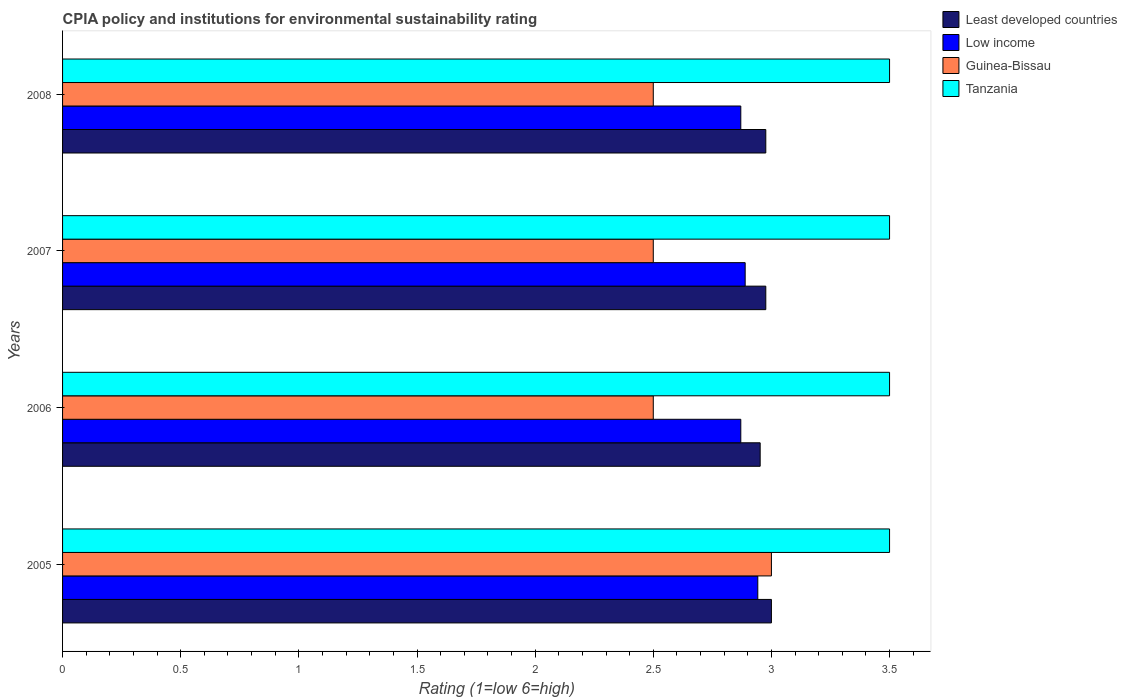How many different coloured bars are there?
Make the answer very short. 4. Are the number of bars per tick equal to the number of legend labels?
Give a very brief answer. Yes. How many bars are there on the 2nd tick from the top?
Give a very brief answer. 4. In how many cases, is the number of bars for a given year not equal to the number of legend labels?
Your response must be concise. 0. Across all years, what is the maximum CPIA rating in Low income?
Your answer should be compact. 2.94. What is the total CPIA rating in Tanzania in the graph?
Your answer should be very brief. 14. What is the difference between the CPIA rating in Least developed countries in 2006 and that in 2007?
Offer a terse response. -0.02. What is the difference between the CPIA rating in Least developed countries in 2006 and the CPIA rating in Tanzania in 2007?
Your response must be concise. -0.55. What is the average CPIA rating in Low income per year?
Offer a very short reply. 2.89. In the year 2006, what is the difference between the CPIA rating in Least developed countries and CPIA rating in Guinea-Bissau?
Keep it short and to the point. 0.45. In how many years, is the CPIA rating in Low income greater than 0.5 ?
Make the answer very short. 4. What is the ratio of the CPIA rating in Least developed countries in 2005 to that in 2006?
Keep it short and to the point. 1.02. Is the CPIA rating in Guinea-Bissau in 2006 less than that in 2008?
Keep it short and to the point. No. Is the difference between the CPIA rating in Least developed countries in 2005 and 2006 greater than the difference between the CPIA rating in Guinea-Bissau in 2005 and 2006?
Provide a succinct answer. No. What is the difference between the highest and the second highest CPIA rating in Guinea-Bissau?
Provide a succinct answer. 0.5. In how many years, is the CPIA rating in Least developed countries greater than the average CPIA rating in Least developed countries taken over all years?
Ensure brevity in your answer.  3. Is the sum of the CPIA rating in Guinea-Bissau in 2006 and 2008 greater than the maximum CPIA rating in Low income across all years?
Provide a short and direct response. Yes. Is it the case that in every year, the sum of the CPIA rating in Low income and CPIA rating in Least developed countries is greater than the sum of CPIA rating in Guinea-Bissau and CPIA rating in Tanzania?
Offer a very short reply. Yes. What does the 4th bar from the top in 2007 represents?
Ensure brevity in your answer.  Least developed countries. What does the 1st bar from the bottom in 2008 represents?
Offer a very short reply. Least developed countries. Is it the case that in every year, the sum of the CPIA rating in Tanzania and CPIA rating in Least developed countries is greater than the CPIA rating in Low income?
Give a very brief answer. Yes. Are all the bars in the graph horizontal?
Provide a short and direct response. Yes. Does the graph contain grids?
Provide a short and direct response. No. Where does the legend appear in the graph?
Your answer should be compact. Top right. What is the title of the graph?
Give a very brief answer. CPIA policy and institutions for environmental sustainability rating. What is the label or title of the X-axis?
Your answer should be very brief. Rating (1=low 6=high). What is the Rating (1=low 6=high) of Least developed countries in 2005?
Offer a terse response. 3. What is the Rating (1=low 6=high) of Low income in 2005?
Keep it short and to the point. 2.94. What is the Rating (1=low 6=high) in Guinea-Bissau in 2005?
Provide a succinct answer. 3. What is the Rating (1=low 6=high) of Least developed countries in 2006?
Provide a short and direct response. 2.95. What is the Rating (1=low 6=high) of Low income in 2006?
Make the answer very short. 2.87. What is the Rating (1=low 6=high) of Tanzania in 2006?
Your response must be concise. 3.5. What is the Rating (1=low 6=high) in Least developed countries in 2007?
Your answer should be very brief. 2.98. What is the Rating (1=low 6=high) in Low income in 2007?
Offer a terse response. 2.89. What is the Rating (1=low 6=high) in Tanzania in 2007?
Keep it short and to the point. 3.5. What is the Rating (1=low 6=high) in Least developed countries in 2008?
Give a very brief answer. 2.98. What is the Rating (1=low 6=high) in Low income in 2008?
Your answer should be compact. 2.87. Across all years, what is the maximum Rating (1=low 6=high) in Low income?
Provide a succinct answer. 2.94. Across all years, what is the maximum Rating (1=low 6=high) of Tanzania?
Your response must be concise. 3.5. Across all years, what is the minimum Rating (1=low 6=high) in Least developed countries?
Give a very brief answer. 2.95. Across all years, what is the minimum Rating (1=low 6=high) in Low income?
Your answer should be very brief. 2.87. What is the total Rating (1=low 6=high) in Least developed countries in the graph?
Ensure brevity in your answer.  11.9. What is the total Rating (1=low 6=high) in Low income in the graph?
Offer a very short reply. 11.57. What is the total Rating (1=low 6=high) of Guinea-Bissau in the graph?
Offer a very short reply. 10.5. What is the total Rating (1=low 6=high) in Tanzania in the graph?
Give a very brief answer. 14. What is the difference between the Rating (1=low 6=high) in Least developed countries in 2005 and that in 2006?
Give a very brief answer. 0.05. What is the difference between the Rating (1=low 6=high) of Low income in 2005 and that in 2006?
Give a very brief answer. 0.07. What is the difference between the Rating (1=low 6=high) in Guinea-Bissau in 2005 and that in 2006?
Ensure brevity in your answer.  0.5. What is the difference between the Rating (1=low 6=high) of Tanzania in 2005 and that in 2006?
Keep it short and to the point. 0. What is the difference between the Rating (1=low 6=high) in Least developed countries in 2005 and that in 2007?
Give a very brief answer. 0.02. What is the difference between the Rating (1=low 6=high) of Low income in 2005 and that in 2007?
Give a very brief answer. 0.05. What is the difference between the Rating (1=low 6=high) of Guinea-Bissau in 2005 and that in 2007?
Offer a very short reply. 0.5. What is the difference between the Rating (1=low 6=high) of Least developed countries in 2005 and that in 2008?
Offer a terse response. 0.02. What is the difference between the Rating (1=low 6=high) of Low income in 2005 and that in 2008?
Give a very brief answer. 0.07. What is the difference between the Rating (1=low 6=high) in Least developed countries in 2006 and that in 2007?
Your response must be concise. -0.02. What is the difference between the Rating (1=low 6=high) in Low income in 2006 and that in 2007?
Offer a very short reply. -0.02. What is the difference between the Rating (1=low 6=high) of Tanzania in 2006 and that in 2007?
Offer a very short reply. 0. What is the difference between the Rating (1=low 6=high) in Least developed countries in 2006 and that in 2008?
Ensure brevity in your answer.  -0.02. What is the difference between the Rating (1=low 6=high) in Tanzania in 2006 and that in 2008?
Keep it short and to the point. 0. What is the difference between the Rating (1=low 6=high) of Low income in 2007 and that in 2008?
Your answer should be compact. 0.02. What is the difference between the Rating (1=low 6=high) in Tanzania in 2007 and that in 2008?
Offer a very short reply. 0. What is the difference between the Rating (1=low 6=high) in Least developed countries in 2005 and the Rating (1=low 6=high) in Low income in 2006?
Your answer should be very brief. 0.13. What is the difference between the Rating (1=low 6=high) in Least developed countries in 2005 and the Rating (1=low 6=high) in Guinea-Bissau in 2006?
Give a very brief answer. 0.5. What is the difference between the Rating (1=low 6=high) in Low income in 2005 and the Rating (1=low 6=high) in Guinea-Bissau in 2006?
Offer a terse response. 0.44. What is the difference between the Rating (1=low 6=high) in Low income in 2005 and the Rating (1=low 6=high) in Tanzania in 2006?
Your answer should be compact. -0.56. What is the difference between the Rating (1=low 6=high) in Guinea-Bissau in 2005 and the Rating (1=low 6=high) in Tanzania in 2006?
Your answer should be very brief. -0.5. What is the difference between the Rating (1=low 6=high) in Least developed countries in 2005 and the Rating (1=low 6=high) in Low income in 2007?
Ensure brevity in your answer.  0.11. What is the difference between the Rating (1=low 6=high) of Least developed countries in 2005 and the Rating (1=low 6=high) of Guinea-Bissau in 2007?
Offer a terse response. 0.5. What is the difference between the Rating (1=low 6=high) in Low income in 2005 and the Rating (1=low 6=high) in Guinea-Bissau in 2007?
Make the answer very short. 0.44. What is the difference between the Rating (1=low 6=high) in Low income in 2005 and the Rating (1=low 6=high) in Tanzania in 2007?
Make the answer very short. -0.56. What is the difference between the Rating (1=low 6=high) of Least developed countries in 2005 and the Rating (1=low 6=high) of Low income in 2008?
Offer a very short reply. 0.13. What is the difference between the Rating (1=low 6=high) in Least developed countries in 2005 and the Rating (1=low 6=high) in Guinea-Bissau in 2008?
Provide a short and direct response. 0.5. What is the difference between the Rating (1=low 6=high) in Least developed countries in 2005 and the Rating (1=low 6=high) in Tanzania in 2008?
Make the answer very short. -0.5. What is the difference between the Rating (1=low 6=high) of Low income in 2005 and the Rating (1=low 6=high) of Guinea-Bissau in 2008?
Keep it short and to the point. 0.44. What is the difference between the Rating (1=low 6=high) in Low income in 2005 and the Rating (1=low 6=high) in Tanzania in 2008?
Give a very brief answer. -0.56. What is the difference between the Rating (1=low 6=high) of Least developed countries in 2006 and the Rating (1=low 6=high) of Low income in 2007?
Make the answer very short. 0.06. What is the difference between the Rating (1=low 6=high) in Least developed countries in 2006 and the Rating (1=low 6=high) in Guinea-Bissau in 2007?
Ensure brevity in your answer.  0.45. What is the difference between the Rating (1=low 6=high) of Least developed countries in 2006 and the Rating (1=low 6=high) of Tanzania in 2007?
Make the answer very short. -0.55. What is the difference between the Rating (1=low 6=high) in Low income in 2006 and the Rating (1=low 6=high) in Guinea-Bissau in 2007?
Make the answer very short. 0.37. What is the difference between the Rating (1=low 6=high) in Low income in 2006 and the Rating (1=low 6=high) in Tanzania in 2007?
Your response must be concise. -0.63. What is the difference between the Rating (1=low 6=high) of Least developed countries in 2006 and the Rating (1=low 6=high) of Low income in 2008?
Give a very brief answer. 0.08. What is the difference between the Rating (1=low 6=high) in Least developed countries in 2006 and the Rating (1=low 6=high) in Guinea-Bissau in 2008?
Your response must be concise. 0.45. What is the difference between the Rating (1=low 6=high) of Least developed countries in 2006 and the Rating (1=low 6=high) of Tanzania in 2008?
Offer a very short reply. -0.55. What is the difference between the Rating (1=low 6=high) of Low income in 2006 and the Rating (1=low 6=high) of Guinea-Bissau in 2008?
Provide a succinct answer. 0.37. What is the difference between the Rating (1=low 6=high) of Low income in 2006 and the Rating (1=low 6=high) of Tanzania in 2008?
Provide a succinct answer. -0.63. What is the difference between the Rating (1=low 6=high) of Guinea-Bissau in 2006 and the Rating (1=low 6=high) of Tanzania in 2008?
Your response must be concise. -1. What is the difference between the Rating (1=low 6=high) of Least developed countries in 2007 and the Rating (1=low 6=high) of Low income in 2008?
Provide a short and direct response. 0.11. What is the difference between the Rating (1=low 6=high) of Least developed countries in 2007 and the Rating (1=low 6=high) of Guinea-Bissau in 2008?
Offer a terse response. 0.48. What is the difference between the Rating (1=low 6=high) in Least developed countries in 2007 and the Rating (1=low 6=high) in Tanzania in 2008?
Provide a short and direct response. -0.52. What is the difference between the Rating (1=low 6=high) of Low income in 2007 and the Rating (1=low 6=high) of Guinea-Bissau in 2008?
Provide a short and direct response. 0.39. What is the difference between the Rating (1=low 6=high) of Low income in 2007 and the Rating (1=low 6=high) of Tanzania in 2008?
Provide a short and direct response. -0.61. What is the difference between the Rating (1=low 6=high) in Guinea-Bissau in 2007 and the Rating (1=low 6=high) in Tanzania in 2008?
Give a very brief answer. -1. What is the average Rating (1=low 6=high) in Least developed countries per year?
Ensure brevity in your answer.  2.98. What is the average Rating (1=low 6=high) of Low income per year?
Your answer should be compact. 2.89. What is the average Rating (1=low 6=high) of Guinea-Bissau per year?
Your response must be concise. 2.62. In the year 2005, what is the difference between the Rating (1=low 6=high) of Least developed countries and Rating (1=low 6=high) of Low income?
Ensure brevity in your answer.  0.06. In the year 2005, what is the difference between the Rating (1=low 6=high) of Least developed countries and Rating (1=low 6=high) of Guinea-Bissau?
Provide a succinct answer. 0. In the year 2005, what is the difference between the Rating (1=low 6=high) of Least developed countries and Rating (1=low 6=high) of Tanzania?
Your response must be concise. -0.5. In the year 2005, what is the difference between the Rating (1=low 6=high) in Low income and Rating (1=low 6=high) in Guinea-Bissau?
Provide a succinct answer. -0.06. In the year 2005, what is the difference between the Rating (1=low 6=high) in Low income and Rating (1=low 6=high) in Tanzania?
Your response must be concise. -0.56. In the year 2005, what is the difference between the Rating (1=low 6=high) of Guinea-Bissau and Rating (1=low 6=high) of Tanzania?
Your response must be concise. -0.5. In the year 2006, what is the difference between the Rating (1=low 6=high) in Least developed countries and Rating (1=low 6=high) in Low income?
Your response must be concise. 0.08. In the year 2006, what is the difference between the Rating (1=low 6=high) of Least developed countries and Rating (1=low 6=high) of Guinea-Bissau?
Your answer should be very brief. 0.45. In the year 2006, what is the difference between the Rating (1=low 6=high) in Least developed countries and Rating (1=low 6=high) in Tanzania?
Offer a very short reply. -0.55. In the year 2006, what is the difference between the Rating (1=low 6=high) in Low income and Rating (1=low 6=high) in Guinea-Bissau?
Keep it short and to the point. 0.37. In the year 2006, what is the difference between the Rating (1=low 6=high) of Low income and Rating (1=low 6=high) of Tanzania?
Keep it short and to the point. -0.63. In the year 2006, what is the difference between the Rating (1=low 6=high) of Guinea-Bissau and Rating (1=low 6=high) of Tanzania?
Your answer should be very brief. -1. In the year 2007, what is the difference between the Rating (1=low 6=high) in Least developed countries and Rating (1=low 6=high) in Low income?
Your answer should be very brief. 0.09. In the year 2007, what is the difference between the Rating (1=low 6=high) in Least developed countries and Rating (1=low 6=high) in Guinea-Bissau?
Give a very brief answer. 0.48. In the year 2007, what is the difference between the Rating (1=low 6=high) of Least developed countries and Rating (1=low 6=high) of Tanzania?
Provide a short and direct response. -0.52. In the year 2007, what is the difference between the Rating (1=low 6=high) in Low income and Rating (1=low 6=high) in Guinea-Bissau?
Offer a very short reply. 0.39. In the year 2007, what is the difference between the Rating (1=low 6=high) in Low income and Rating (1=low 6=high) in Tanzania?
Offer a terse response. -0.61. In the year 2008, what is the difference between the Rating (1=low 6=high) in Least developed countries and Rating (1=low 6=high) in Low income?
Provide a short and direct response. 0.11. In the year 2008, what is the difference between the Rating (1=low 6=high) in Least developed countries and Rating (1=low 6=high) in Guinea-Bissau?
Provide a short and direct response. 0.48. In the year 2008, what is the difference between the Rating (1=low 6=high) in Least developed countries and Rating (1=low 6=high) in Tanzania?
Your response must be concise. -0.52. In the year 2008, what is the difference between the Rating (1=low 6=high) of Low income and Rating (1=low 6=high) of Guinea-Bissau?
Your response must be concise. 0.37. In the year 2008, what is the difference between the Rating (1=low 6=high) in Low income and Rating (1=low 6=high) in Tanzania?
Keep it short and to the point. -0.63. In the year 2008, what is the difference between the Rating (1=low 6=high) in Guinea-Bissau and Rating (1=low 6=high) in Tanzania?
Provide a short and direct response. -1. What is the ratio of the Rating (1=low 6=high) in Least developed countries in 2005 to that in 2006?
Provide a short and direct response. 1.02. What is the ratio of the Rating (1=low 6=high) in Low income in 2005 to that in 2006?
Offer a terse response. 1.03. What is the ratio of the Rating (1=low 6=high) in Low income in 2005 to that in 2007?
Give a very brief answer. 1.02. What is the ratio of the Rating (1=low 6=high) in Least developed countries in 2005 to that in 2008?
Provide a succinct answer. 1.01. What is the ratio of the Rating (1=low 6=high) in Low income in 2005 to that in 2008?
Make the answer very short. 1.03. What is the ratio of the Rating (1=low 6=high) of Low income in 2006 to that in 2007?
Your response must be concise. 0.99. What is the ratio of the Rating (1=low 6=high) of Tanzania in 2006 to that in 2007?
Offer a terse response. 1. What is the ratio of the Rating (1=low 6=high) of Low income in 2006 to that in 2008?
Provide a short and direct response. 1. What is the ratio of the Rating (1=low 6=high) in Tanzania in 2006 to that in 2008?
Provide a short and direct response. 1. What is the ratio of the Rating (1=low 6=high) in Low income in 2007 to that in 2008?
Keep it short and to the point. 1.01. What is the ratio of the Rating (1=low 6=high) in Guinea-Bissau in 2007 to that in 2008?
Give a very brief answer. 1. What is the difference between the highest and the second highest Rating (1=low 6=high) of Least developed countries?
Give a very brief answer. 0.02. What is the difference between the highest and the second highest Rating (1=low 6=high) of Low income?
Ensure brevity in your answer.  0.05. What is the difference between the highest and the lowest Rating (1=low 6=high) in Least developed countries?
Provide a short and direct response. 0.05. What is the difference between the highest and the lowest Rating (1=low 6=high) of Low income?
Make the answer very short. 0.07. What is the difference between the highest and the lowest Rating (1=low 6=high) in Tanzania?
Provide a succinct answer. 0. 